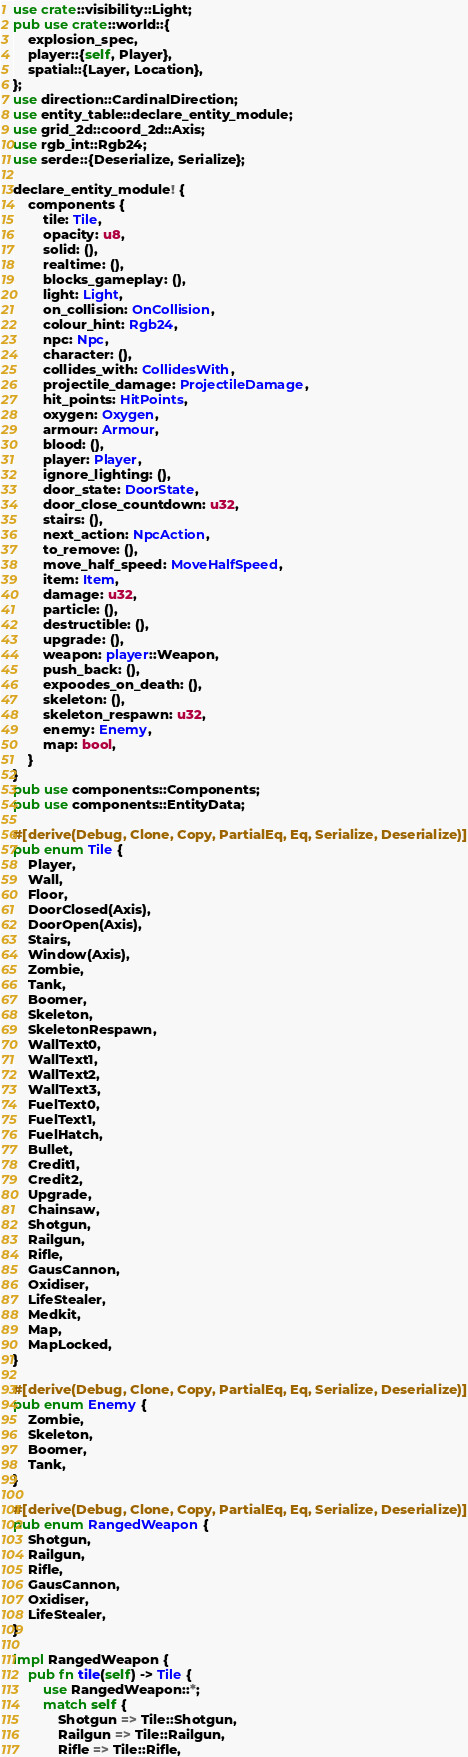Convert code to text. <code><loc_0><loc_0><loc_500><loc_500><_Rust_>use crate::visibility::Light;
pub use crate::world::{
    explosion_spec,
    player::{self, Player},
    spatial::{Layer, Location},
};
use direction::CardinalDirection;
use entity_table::declare_entity_module;
use grid_2d::coord_2d::Axis;
use rgb_int::Rgb24;
use serde::{Deserialize, Serialize};

declare_entity_module! {
    components {
        tile: Tile,
        opacity: u8,
        solid: (),
        realtime: (),
        blocks_gameplay: (),
        light: Light,
        on_collision: OnCollision,
        colour_hint: Rgb24,
        npc: Npc,
        character: (),
        collides_with: CollidesWith,
        projectile_damage: ProjectileDamage,
        hit_points: HitPoints,
        oxygen: Oxygen,
        armour: Armour,
        blood: (),
        player: Player,
        ignore_lighting: (),
        door_state: DoorState,
        door_close_countdown: u32,
        stairs: (),
        next_action: NpcAction,
        to_remove: (),
        move_half_speed: MoveHalfSpeed,
        item: Item,
        damage: u32,
        particle: (),
        destructible: (),
        upgrade: (),
        weapon: player::Weapon,
        push_back: (),
        expoodes_on_death: (),
        skeleton: (),
        skeleton_respawn: u32,
        enemy: Enemy,
        map: bool,
    }
}
pub use components::Components;
pub use components::EntityData;

#[derive(Debug, Clone, Copy, PartialEq, Eq, Serialize, Deserialize)]
pub enum Tile {
    Player,
    Wall,
    Floor,
    DoorClosed(Axis),
    DoorOpen(Axis),
    Stairs,
    Window(Axis),
    Zombie,
    Tank,
    Boomer,
    Skeleton,
    SkeletonRespawn,
    WallText0,
    WallText1,
    WallText2,
    WallText3,
    FuelText0,
    FuelText1,
    FuelHatch,
    Bullet,
    Credit1,
    Credit2,
    Upgrade,
    Chainsaw,
    Shotgun,
    Railgun,
    Rifle,
    GausCannon,
    Oxidiser,
    LifeStealer,
    Medkit,
    Map,
    MapLocked,
}

#[derive(Debug, Clone, Copy, PartialEq, Eq, Serialize, Deserialize)]
pub enum Enemy {
    Zombie,
    Skeleton,
    Boomer,
    Tank,
}

#[derive(Debug, Clone, Copy, PartialEq, Eq, Serialize, Deserialize)]
pub enum RangedWeapon {
    Shotgun,
    Railgun,
    Rifle,
    GausCannon,
    Oxidiser,
    LifeStealer,
}

impl RangedWeapon {
    pub fn tile(self) -> Tile {
        use RangedWeapon::*;
        match self {
            Shotgun => Tile::Shotgun,
            Railgun => Tile::Railgun,
            Rifle => Tile::Rifle,</code> 